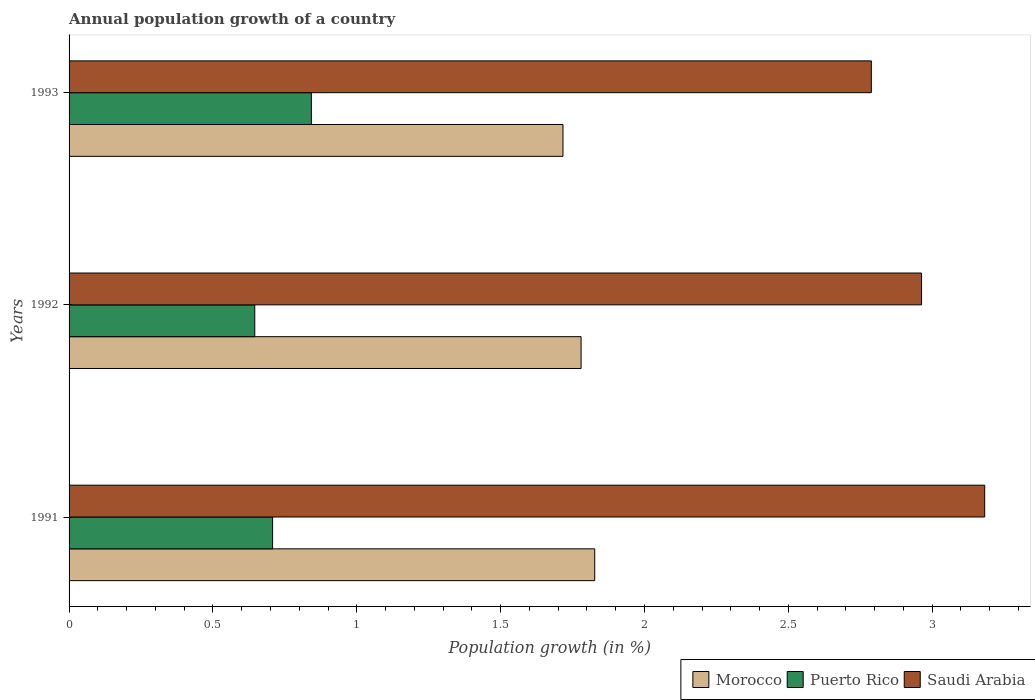How many different coloured bars are there?
Your answer should be very brief. 3. How many bars are there on the 2nd tick from the bottom?
Keep it short and to the point. 3. In how many cases, is the number of bars for a given year not equal to the number of legend labels?
Keep it short and to the point. 0. What is the annual population growth in Puerto Rico in 1992?
Offer a very short reply. 0.65. Across all years, what is the maximum annual population growth in Saudi Arabia?
Your answer should be very brief. 3.18. Across all years, what is the minimum annual population growth in Morocco?
Your response must be concise. 1.72. In which year was the annual population growth in Morocco maximum?
Provide a short and direct response. 1991. In which year was the annual population growth in Morocco minimum?
Provide a short and direct response. 1993. What is the total annual population growth in Saudi Arabia in the graph?
Ensure brevity in your answer.  8.93. What is the difference between the annual population growth in Saudi Arabia in 1991 and that in 1992?
Ensure brevity in your answer.  0.22. What is the difference between the annual population growth in Puerto Rico in 1992 and the annual population growth in Saudi Arabia in 1991?
Your answer should be compact. -2.54. What is the average annual population growth in Puerto Rico per year?
Make the answer very short. 0.73. In the year 1993, what is the difference between the annual population growth in Saudi Arabia and annual population growth in Morocco?
Your answer should be compact. 1.07. What is the ratio of the annual population growth in Saudi Arabia in 1991 to that in 1993?
Make the answer very short. 1.14. Is the annual population growth in Saudi Arabia in 1991 less than that in 1992?
Provide a short and direct response. No. Is the difference between the annual population growth in Saudi Arabia in 1991 and 1992 greater than the difference between the annual population growth in Morocco in 1991 and 1992?
Your response must be concise. Yes. What is the difference between the highest and the second highest annual population growth in Saudi Arabia?
Offer a very short reply. 0.22. What is the difference between the highest and the lowest annual population growth in Morocco?
Make the answer very short. 0.11. What does the 2nd bar from the top in 1993 represents?
Your response must be concise. Puerto Rico. What does the 3rd bar from the bottom in 1993 represents?
Your answer should be very brief. Saudi Arabia. How many bars are there?
Keep it short and to the point. 9. Are all the bars in the graph horizontal?
Make the answer very short. Yes. How many years are there in the graph?
Ensure brevity in your answer.  3. What is the difference between two consecutive major ticks on the X-axis?
Your answer should be compact. 0.5. Does the graph contain any zero values?
Keep it short and to the point. No. Does the graph contain grids?
Your answer should be compact. No. Where does the legend appear in the graph?
Your response must be concise. Bottom right. How are the legend labels stacked?
Make the answer very short. Horizontal. What is the title of the graph?
Your response must be concise. Annual population growth of a country. Does "Finland" appear as one of the legend labels in the graph?
Offer a terse response. No. What is the label or title of the X-axis?
Your answer should be very brief. Population growth (in %). What is the label or title of the Y-axis?
Provide a short and direct response. Years. What is the Population growth (in %) of Morocco in 1991?
Ensure brevity in your answer.  1.83. What is the Population growth (in %) of Puerto Rico in 1991?
Provide a short and direct response. 0.71. What is the Population growth (in %) in Saudi Arabia in 1991?
Ensure brevity in your answer.  3.18. What is the Population growth (in %) of Morocco in 1992?
Keep it short and to the point. 1.78. What is the Population growth (in %) of Puerto Rico in 1992?
Your answer should be compact. 0.65. What is the Population growth (in %) of Saudi Arabia in 1992?
Provide a short and direct response. 2.96. What is the Population growth (in %) in Morocco in 1993?
Your answer should be very brief. 1.72. What is the Population growth (in %) of Puerto Rico in 1993?
Make the answer very short. 0.84. What is the Population growth (in %) of Saudi Arabia in 1993?
Make the answer very short. 2.79. Across all years, what is the maximum Population growth (in %) of Morocco?
Ensure brevity in your answer.  1.83. Across all years, what is the maximum Population growth (in %) of Puerto Rico?
Make the answer very short. 0.84. Across all years, what is the maximum Population growth (in %) of Saudi Arabia?
Your answer should be compact. 3.18. Across all years, what is the minimum Population growth (in %) in Morocco?
Offer a terse response. 1.72. Across all years, what is the minimum Population growth (in %) in Puerto Rico?
Keep it short and to the point. 0.65. Across all years, what is the minimum Population growth (in %) of Saudi Arabia?
Your answer should be compact. 2.79. What is the total Population growth (in %) of Morocco in the graph?
Give a very brief answer. 5.32. What is the total Population growth (in %) in Puerto Rico in the graph?
Ensure brevity in your answer.  2.19. What is the total Population growth (in %) in Saudi Arabia in the graph?
Provide a succinct answer. 8.93. What is the difference between the Population growth (in %) of Morocco in 1991 and that in 1992?
Ensure brevity in your answer.  0.05. What is the difference between the Population growth (in %) in Puerto Rico in 1991 and that in 1992?
Ensure brevity in your answer.  0.06. What is the difference between the Population growth (in %) in Saudi Arabia in 1991 and that in 1992?
Offer a very short reply. 0.22. What is the difference between the Population growth (in %) of Morocco in 1991 and that in 1993?
Your response must be concise. 0.11. What is the difference between the Population growth (in %) in Puerto Rico in 1991 and that in 1993?
Ensure brevity in your answer.  -0.13. What is the difference between the Population growth (in %) in Saudi Arabia in 1991 and that in 1993?
Ensure brevity in your answer.  0.39. What is the difference between the Population growth (in %) in Morocco in 1992 and that in 1993?
Ensure brevity in your answer.  0.06. What is the difference between the Population growth (in %) of Puerto Rico in 1992 and that in 1993?
Give a very brief answer. -0.2. What is the difference between the Population growth (in %) of Saudi Arabia in 1992 and that in 1993?
Keep it short and to the point. 0.17. What is the difference between the Population growth (in %) of Morocco in 1991 and the Population growth (in %) of Puerto Rico in 1992?
Provide a succinct answer. 1.18. What is the difference between the Population growth (in %) in Morocco in 1991 and the Population growth (in %) in Saudi Arabia in 1992?
Make the answer very short. -1.14. What is the difference between the Population growth (in %) in Puerto Rico in 1991 and the Population growth (in %) in Saudi Arabia in 1992?
Give a very brief answer. -2.26. What is the difference between the Population growth (in %) of Morocco in 1991 and the Population growth (in %) of Puerto Rico in 1993?
Provide a succinct answer. 0.98. What is the difference between the Population growth (in %) in Morocco in 1991 and the Population growth (in %) in Saudi Arabia in 1993?
Offer a terse response. -0.96. What is the difference between the Population growth (in %) of Puerto Rico in 1991 and the Population growth (in %) of Saudi Arabia in 1993?
Ensure brevity in your answer.  -2.08. What is the difference between the Population growth (in %) in Morocco in 1992 and the Population growth (in %) in Puerto Rico in 1993?
Keep it short and to the point. 0.94. What is the difference between the Population growth (in %) of Morocco in 1992 and the Population growth (in %) of Saudi Arabia in 1993?
Keep it short and to the point. -1.01. What is the difference between the Population growth (in %) of Puerto Rico in 1992 and the Population growth (in %) of Saudi Arabia in 1993?
Make the answer very short. -2.14. What is the average Population growth (in %) in Morocco per year?
Your answer should be very brief. 1.77. What is the average Population growth (in %) of Puerto Rico per year?
Ensure brevity in your answer.  0.73. What is the average Population growth (in %) in Saudi Arabia per year?
Give a very brief answer. 2.98. In the year 1991, what is the difference between the Population growth (in %) of Morocco and Population growth (in %) of Puerto Rico?
Keep it short and to the point. 1.12. In the year 1991, what is the difference between the Population growth (in %) of Morocco and Population growth (in %) of Saudi Arabia?
Provide a succinct answer. -1.36. In the year 1991, what is the difference between the Population growth (in %) in Puerto Rico and Population growth (in %) in Saudi Arabia?
Your answer should be very brief. -2.48. In the year 1992, what is the difference between the Population growth (in %) in Morocco and Population growth (in %) in Puerto Rico?
Make the answer very short. 1.13. In the year 1992, what is the difference between the Population growth (in %) in Morocco and Population growth (in %) in Saudi Arabia?
Provide a succinct answer. -1.18. In the year 1992, what is the difference between the Population growth (in %) of Puerto Rico and Population growth (in %) of Saudi Arabia?
Make the answer very short. -2.32. In the year 1993, what is the difference between the Population growth (in %) of Morocco and Population growth (in %) of Puerto Rico?
Provide a short and direct response. 0.87. In the year 1993, what is the difference between the Population growth (in %) in Morocco and Population growth (in %) in Saudi Arabia?
Offer a terse response. -1.07. In the year 1993, what is the difference between the Population growth (in %) in Puerto Rico and Population growth (in %) in Saudi Arabia?
Make the answer very short. -1.95. What is the ratio of the Population growth (in %) in Morocco in 1991 to that in 1992?
Offer a very short reply. 1.03. What is the ratio of the Population growth (in %) in Puerto Rico in 1991 to that in 1992?
Ensure brevity in your answer.  1.1. What is the ratio of the Population growth (in %) in Saudi Arabia in 1991 to that in 1992?
Give a very brief answer. 1.07. What is the ratio of the Population growth (in %) in Morocco in 1991 to that in 1993?
Provide a short and direct response. 1.06. What is the ratio of the Population growth (in %) in Puerto Rico in 1991 to that in 1993?
Provide a succinct answer. 0.84. What is the ratio of the Population growth (in %) in Saudi Arabia in 1991 to that in 1993?
Your answer should be very brief. 1.14. What is the ratio of the Population growth (in %) of Morocco in 1992 to that in 1993?
Keep it short and to the point. 1.04. What is the ratio of the Population growth (in %) of Puerto Rico in 1992 to that in 1993?
Provide a succinct answer. 0.77. What is the ratio of the Population growth (in %) of Saudi Arabia in 1992 to that in 1993?
Give a very brief answer. 1.06. What is the difference between the highest and the second highest Population growth (in %) in Morocco?
Your answer should be very brief. 0.05. What is the difference between the highest and the second highest Population growth (in %) of Puerto Rico?
Ensure brevity in your answer.  0.13. What is the difference between the highest and the second highest Population growth (in %) of Saudi Arabia?
Offer a very short reply. 0.22. What is the difference between the highest and the lowest Population growth (in %) in Morocco?
Offer a very short reply. 0.11. What is the difference between the highest and the lowest Population growth (in %) in Puerto Rico?
Your answer should be compact. 0.2. What is the difference between the highest and the lowest Population growth (in %) in Saudi Arabia?
Keep it short and to the point. 0.39. 